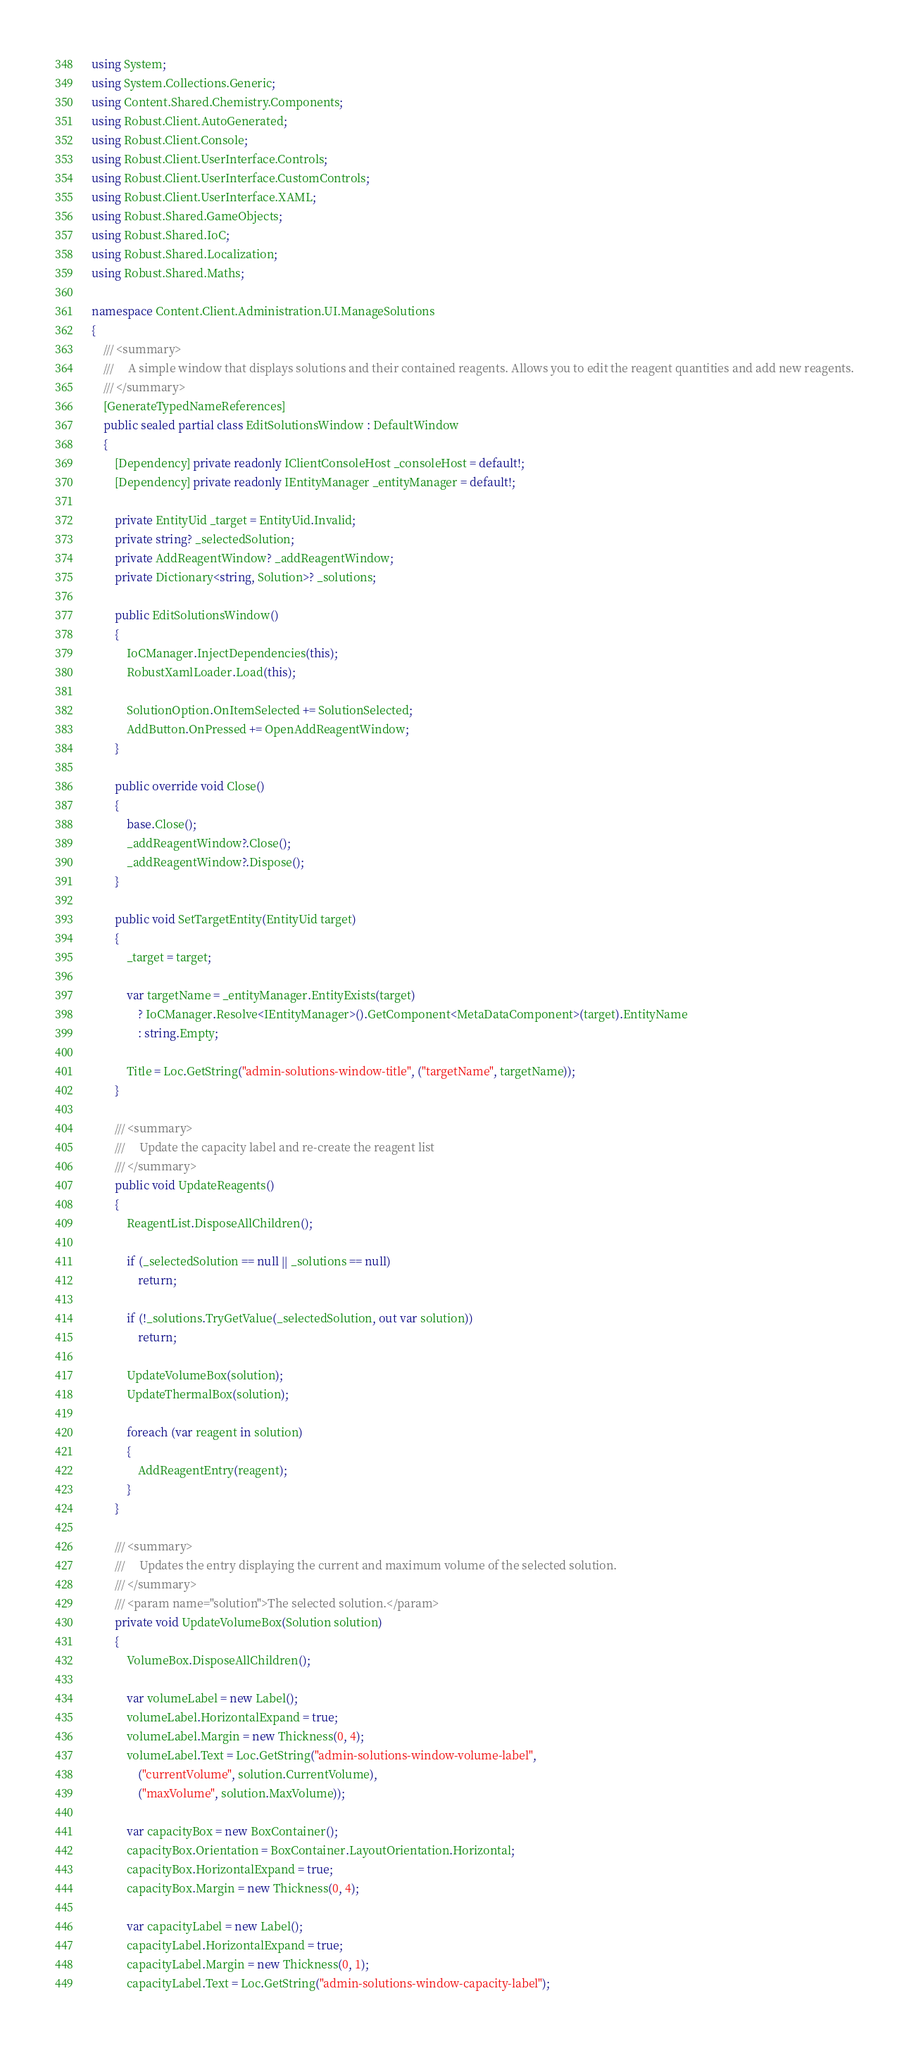Convert code to text. <code><loc_0><loc_0><loc_500><loc_500><_C#_>using System;
using System.Collections.Generic;
using Content.Shared.Chemistry.Components;
using Robust.Client.AutoGenerated;
using Robust.Client.Console;
using Robust.Client.UserInterface.Controls;
using Robust.Client.UserInterface.CustomControls;
using Robust.Client.UserInterface.XAML;
using Robust.Shared.GameObjects;
using Robust.Shared.IoC;
using Robust.Shared.Localization;
using Robust.Shared.Maths;

namespace Content.Client.Administration.UI.ManageSolutions
{
    /// <summary>
    ///     A simple window that displays solutions and their contained reagents. Allows you to edit the reagent quantities and add new reagents.
    /// </summary>
    [GenerateTypedNameReferences]
    public sealed partial class EditSolutionsWindow : DefaultWindow
    {
        [Dependency] private readonly IClientConsoleHost _consoleHost = default!;
        [Dependency] private readonly IEntityManager _entityManager = default!;

        private EntityUid _target = EntityUid.Invalid;
        private string? _selectedSolution;
        private AddReagentWindow? _addReagentWindow;
        private Dictionary<string, Solution>? _solutions;

        public EditSolutionsWindow()
        {
            IoCManager.InjectDependencies(this);
            RobustXamlLoader.Load(this);

            SolutionOption.OnItemSelected += SolutionSelected;
            AddButton.OnPressed += OpenAddReagentWindow;
        }

        public override void Close()
        {
            base.Close();
            _addReagentWindow?.Close();
            _addReagentWindow?.Dispose();
        }

        public void SetTargetEntity(EntityUid target)
        {
            _target = target;

            var targetName = _entityManager.EntityExists(target)
                ? IoCManager.Resolve<IEntityManager>().GetComponent<MetaDataComponent>(target).EntityName
                : string.Empty;

            Title = Loc.GetString("admin-solutions-window-title", ("targetName", targetName));
        }

        /// <summary>
        ///     Update the capacity label and re-create the reagent list
        /// </summary>
        public void UpdateReagents()
        {
            ReagentList.DisposeAllChildren();

            if (_selectedSolution == null || _solutions == null)
                return;

            if (!_solutions.TryGetValue(_selectedSolution, out var solution))
                return;

            UpdateVolumeBox(solution);
            UpdateThermalBox(solution);

            foreach (var reagent in solution)
            {
                AddReagentEntry(reagent);
            }
        }

        /// <summary>
        ///     Updates the entry displaying the current and maximum volume of the selected solution.
        /// </summary>
        /// <param name="solution">The selected solution.</param>
        private void UpdateVolumeBox(Solution solution)
        {
            VolumeBox.DisposeAllChildren();

            var volumeLabel = new Label();
            volumeLabel.HorizontalExpand = true;
            volumeLabel.Margin = new Thickness(0, 4);
            volumeLabel.Text = Loc.GetString("admin-solutions-window-volume-label",
                ("currentVolume", solution.CurrentVolume),
                ("maxVolume", solution.MaxVolume));

            var capacityBox = new BoxContainer();
            capacityBox.Orientation = BoxContainer.LayoutOrientation.Horizontal;
            capacityBox.HorizontalExpand = true;
            capacityBox.Margin = new Thickness(0, 4);

            var capacityLabel = new Label();
            capacityLabel.HorizontalExpand = true;
            capacityLabel.Margin = new Thickness(0, 1);
            capacityLabel.Text = Loc.GetString("admin-solutions-window-capacity-label");
</code> 